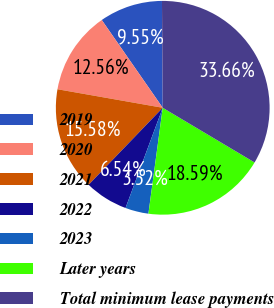Convert chart to OTSL. <chart><loc_0><loc_0><loc_500><loc_500><pie_chart><fcel>2019<fcel>2020<fcel>2021<fcel>2022<fcel>2023<fcel>Later years<fcel>Total minimum lease payments<nl><fcel>9.55%<fcel>12.56%<fcel>15.58%<fcel>6.54%<fcel>3.52%<fcel>18.59%<fcel>33.66%<nl></chart> 